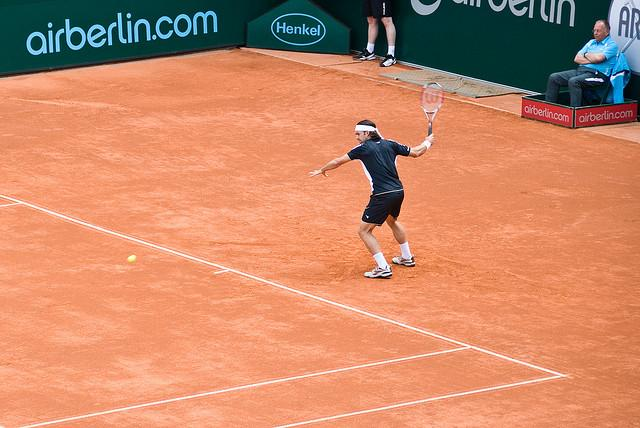In which country is the city mentioned here located?

Choices:
A) austria
B) france
C) germany
D) us germany 